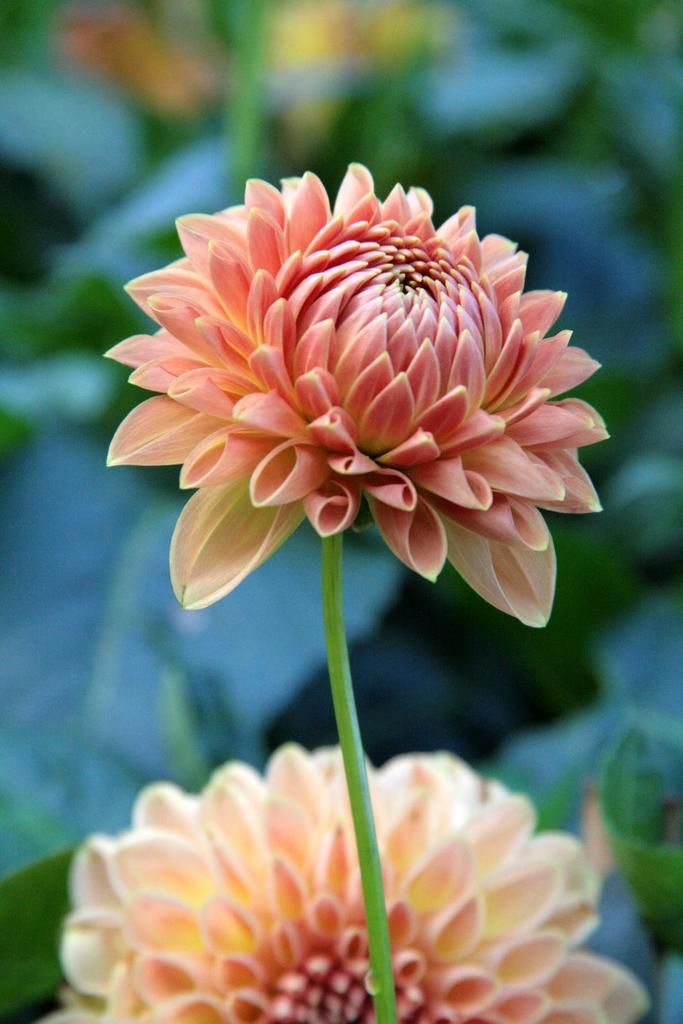Where was the image most likely taken? The image was likely taken indoors. What can be seen in the foreground of the image? There are two flowers and a stem in the foreground of the image. How would you describe the background of the image? The background of the image is blurry. What type of vegetation is visible in the background? Leaves are visible in the background of the image. Can you identify any other plants in the image? Yes, there is a plant in the background of the image. What type of clouds can be seen through the window in the image? There is no window or clouds visible in the image. Can you tell me what your dad is doing in the image? There is no person, including a dad, present in the image. Is there a stove visible in the image? No, there is no stove present in the image. 